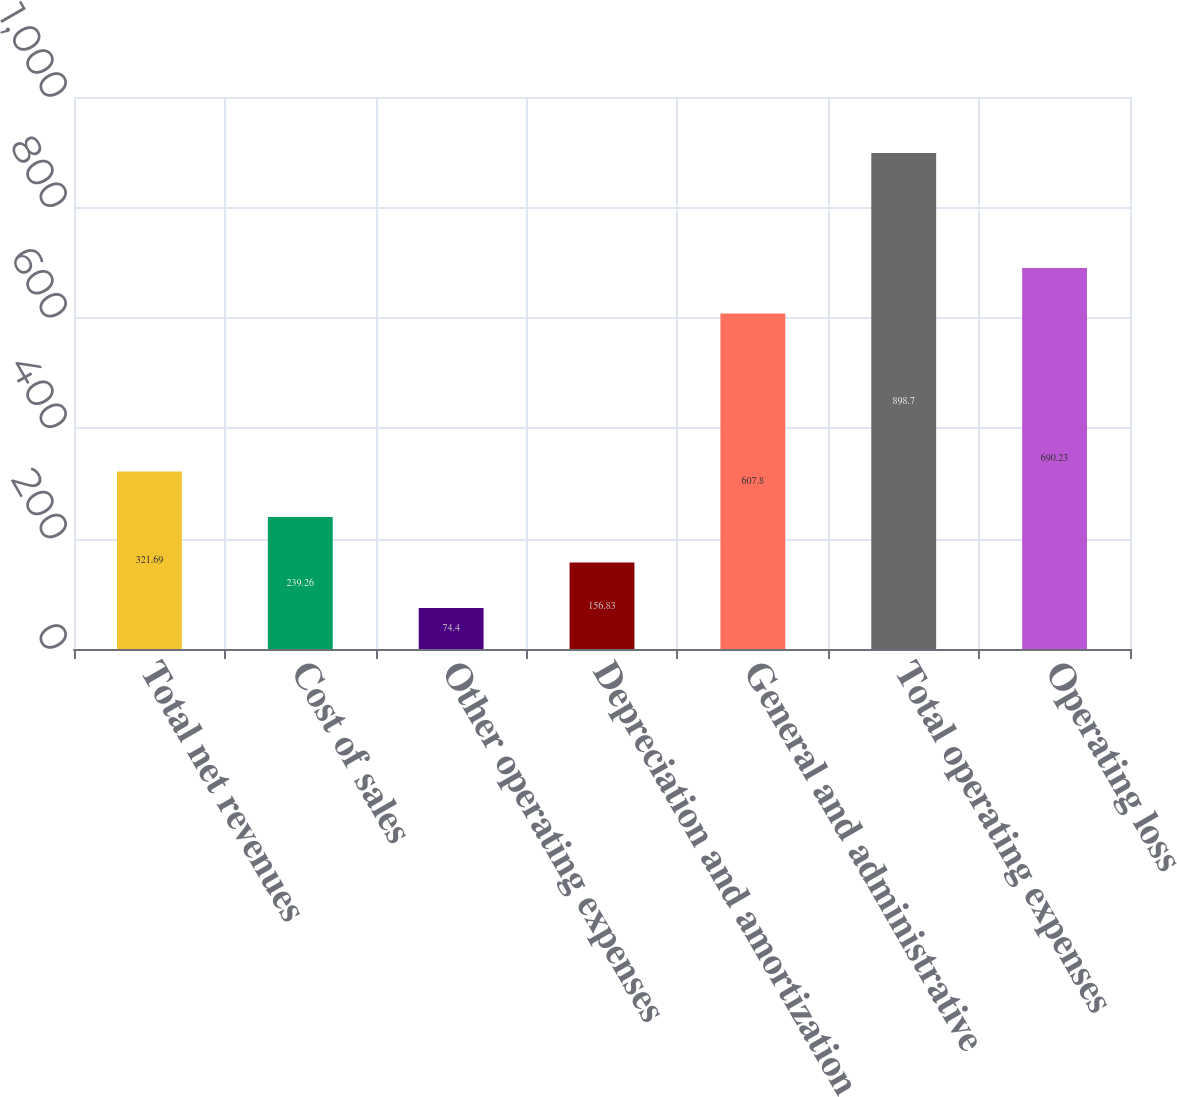<chart> <loc_0><loc_0><loc_500><loc_500><bar_chart><fcel>Total net revenues<fcel>Cost of sales<fcel>Other operating expenses<fcel>Depreciation and amortization<fcel>General and administrative<fcel>Total operating expenses<fcel>Operating loss<nl><fcel>321.69<fcel>239.26<fcel>74.4<fcel>156.83<fcel>607.8<fcel>898.7<fcel>690.23<nl></chart> 